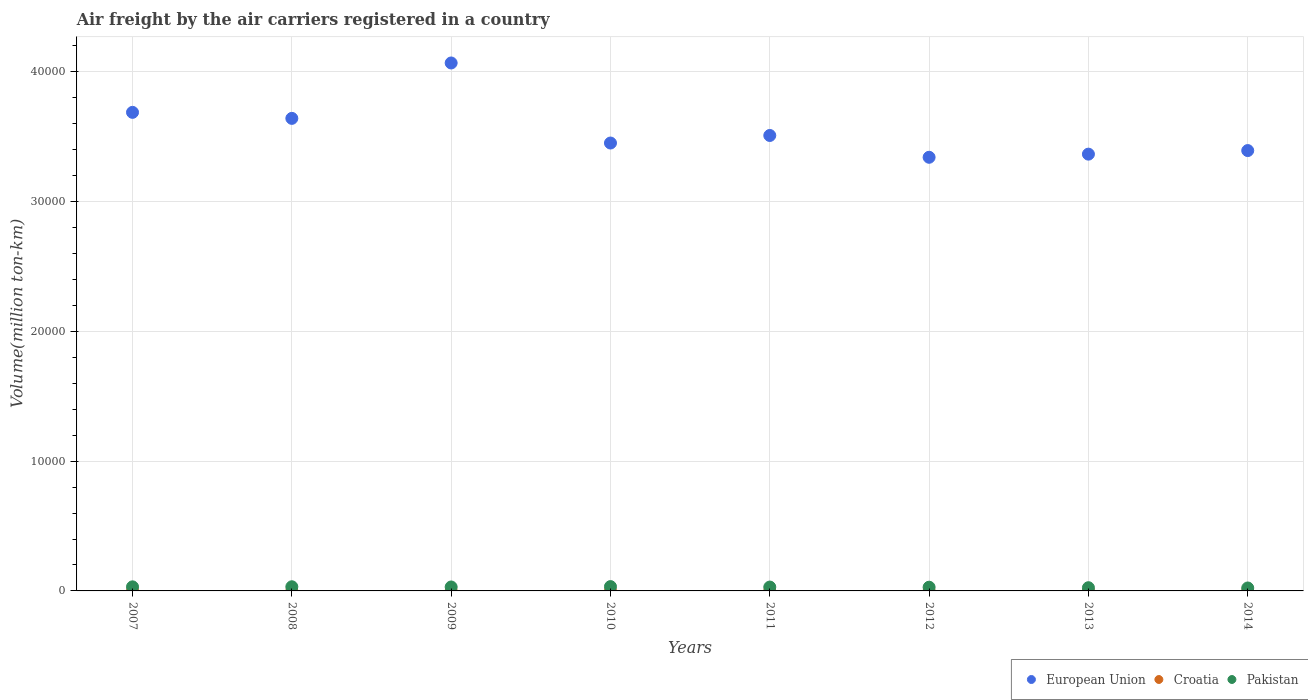Is the number of dotlines equal to the number of legend labels?
Ensure brevity in your answer.  Yes. What is the volume of the air carriers in Pakistan in 2010?
Offer a terse response. 332.96. Across all years, what is the maximum volume of the air carriers in Pakistan?
Offer a very short reply. 332.96. Across all years, what is the minimum volume of the air carriers in European Union?
Make the answer very short. 3.34e+04. What is the total volume of the air carriers in European Union in the graph?
Make the answer very short. 2.85e+05. What is the difference between the volume of the air carriers in European Union in 2012 and that in 2013?
Offer a terse response. -241.89. What is the difference between the volume of the air carriers in Pakistan in 2010 and the volume of the air carriers in European Union in 2008?
Keep it short and to the point. -3.61e+04. What is the average volume of the air carriers in Pakistan per year?
Your response must be concise. 291.08. In the year 2008, what is the difference between the volume of the air carriers in Pakistan and volume of the air carriers in Croatia?
Your answer should be very brief. 317.47. What is the ratio of the volume of the air carriers in Croatia in 2009 to that in 2010?
Your answer should be compact. 1.27. Is the volume of the air carriers in Pakistan in 2007 less than that in 2014?
Provide a succinct answer. No. Is the difference between the volume of the air carriers in Pakistan in 2007 and 2009 greater than the difference between the volume of the air carriers in Croatia in 2007 and 2009?
Your answer should be compact. Yes. What is the difference between the highest and the second highest volume of the air carriers in Pakistan?
Make the answer very short. 13.16. What is the difference between the highest and the lowest volume of the air carriers in Pakistan?
Offer a very short reply. 106.21. In how many years, is the volume of the air carriers in Croatia greater than the average volume of the air carriers in Croatia taken over all years?
Offer a terse response. 4. Is the sum of the volume of the air carriers in European Union in 2007 and 2010 greater than the maximum volume of the air carriers in Pakistan across all years?
Provide a succinct answer. Yes. Does the volume of the air carriers in Croatia monotonically increase over the years?
Offer a terse response. No. Is the volume of the air carriers in European Union strictly greater than the volume of the air carriers in Croatia over the years?
Make the answer very short. Yes. How many years are there in the graph?
Make the answer very short. 8. What is the difference between two consecutive major ticks on the Y-axis?
Your response must be concise. 10000. Does the graph contain any zero values?
Your response must be concise. No. How many legend labels are there?
Give a very brief answer. 3. How are the legend labels stacked?
Your answer should be compact. Horizontal. What is the title of the graph?
Provide a succinct answer. Air freight by the air carriers registered in a country. Does "France" appear as one of the legend labels in the graph?
Your answer should be compact. No. What is the label or title of the X-axis?
Provide a short and direct response. Years. What is the label or title of the Y-axis?
Ensure brevity in your answer.  Volume(million ton-km). What is the Volume(million ton-km) in European Union in 2007?
Ensure brevity in your answer.  3.69e+04. What is the Volume(million ton-km) in Croatia in 2007?
Give a very brief answer. 2.22. What is the Volume(million ton-km) of Pakistan in 2007?
Offer a terse response. 313.87. What is the Volume(million ton-km) in European Union in 2008?
Give a very brief answer. 3.64e+04. What is the Volume(million ton-km) in Croatia in 2008?
Make the answer very short. 2.33. What is the Volume(million ton-km) of Pakistan in 2008?
Your response must be concise. 319.8. What is the Volume(million ton-km) in European Union in 2009?
Make the answer very short. 4.07e+04. What is the Volume(million ton-km) in Croatia in 2009?
Offer a very short reply. 1.92. What is the Volume(million ton-km) of Pakistan in 2009?
Your answer should be compact. 303.9. What is the Volume(million ton-km) in European Union in 2010?
Make the answer very short. 3.45e+04. What is the Volume(million ton-km) in Croatia in 2010?
Your answer should be very brief. 1.52. What is the Volume(million ton-km) in Pakistan in 2010?
Provide a short and direct response. 332.96. What is the Volume(million ton-km) in European Union in 2011?
Give a very brief answer. 3.51e+04. What is the Volume(million ton-km) of Croatia in 2011?
Provide a succinct answer. 1.67. What is the Volume(million ton-km) of Pakistan in 2011?
Your response must be concise. 297.68. What is the Volume(million ton-km) in European Union in 2012?
Offer a terse response. 3.34e+04. What is the Volume(million ton-km) of Croatia in 2012?
Provide a succinct answer. 1.74. What is the Volume(million ton-km) of Pakistan in 2012?
Provide a succinct answer. 286.08. What is the Volume(million ton-km) in European Union in 2013?
Offer a very short reply. 3.37e+04. What is the Volume(million ton-km) in Croatia in 2013?
Provide a succinct answer. 1.47. What is the Volume(million ton-km) of Pakistan in 2013?
Offer a very short reply. 247.6. What is the Volume(million ton-km) in European Union in 2014?
Offer a very short reply. 3.39e+04. What is the Volume(million ton-km) in Croatia in 2014?
Your response must be concise. 0.98. What is the Volume(million ton-km) of Pakistan in 2014?
Ensure brevity in your answer.  226.75. Across all years, what is the maximum Volume(million ton-km) in European Union?
Provide a succinct answer. 4.07e+04. Across all years, what is the maximum Volume(million ton-km) of Croatia?
Keep it short and to the point. 2.33. Across all years, what is the maximum Volume(million ton-km) of Pakistan?
Offer a terse response. 332.96. Across all years, what is the minimum Volume(million ton-km) of European Union?
Give a very brief answer. 3.34e+04. Across all years, what is the minimum Volume(million ton-km) of Croatia?
Make the answer very short. 0.98. Across all years, what is the minimum Volume(million ton-km) in Pakistan?
Offer a very short reply. 226.75. What is the total Volume(million ton-km) of European Union in the graph?
Offer a terse response. 2.85e+05. What is the total Volume(million ton-km) of Croatia in the graph?
Offer a very short reply. 13.84. What is the total Volume(million ton-km) of Pakistan in the graph?
Your answer should be compact. 2328.64. What is the difference between the Volume(million ton-km) in European Union in 2007 and that in 2008?
Offer a very short reply. 463.57. What is the difference between the Volume(million ton-km) in Croatia in 2007 and that in 2008?
Provide a succinct answer. -0.11. What is the difference between the Volume(million ton-km) of Pakistan in 2007 and that in 2008?
Your answer should be very brief. -5.92. What is the difference between the Volume(million ton-km) in European Union in 2007 and that in 2009?
Provide a short and direct response. -3805.88. What is the difference between the Volume(million ton-km) of Croatia in 2007 and that in 2009?
Make the answer very short. 0.3. What is the difference between the Volume(million ton-km) of Pakistan in 2007 and that in 2009?
Offer a terse response. 9.97. What is the difference between the Volume(million ton-km) in European Union in 2007 and that in 2010?
Your answer should be compact. 2363.75. What is the difference between the Volume(million ton-km) in Croatia in 2007 and that in 2010?
Your answer should be very brief. 0.7. What is the difference between the Volume(million ton-km) in Pakistan in 2007 and that in 2010?
Your answer should be very brief. -19.09. What is the difference between the Volume(million ton-km) of European Union in 2007 and that in 2011?
Provide a succinct answer. 1781.69. What is the difference between the Volume(million ton-km) of Croatia in 2007 and that in 2011?
Offer a terse response. 0.54. What is the difference between the Volume(million ton-km) in Pakistan in 2007 and that in 2011?
Your answer should be very brief. 16.19. What is the difference between the Volume(million ton-km) of European Union in 2007 and that in 2012?
Your answer should be compact. 3461.98. What is the difference between the Volume(million ton-km) in Croatia in 2007 and that in 2012?
Ensure brevity in your answer.  0.48. What is the difference between the Volume(million ton-km) in Pakistan in 2007 and that in 2012?
Offer a very short reply. 27.8. What is the difference between the Volume(million ton-km) of European Union in 2007 and that in 2013?
Keep it short and to the point. 3220.09. What is the difference between the Volume(million ton-km) in Croatia in 2007 and that in 2013?
Your answer should be very brief. 0.75. What is the difference between the Volume(million ton-km) in Pakistan in 2007 and that in 2013?
Your answer should be very brief. 66.27. What is the difference between the Volume(million ton-km) of European Union in 2007 and that in 2014?
Offer a very short reply. 2944.59. What is the difference between the Volume(million ton-km) of Croatia in 2007 and that in 2014?
Offer a terse response. 1.24. What is the difference between the Volume(million ton-km) in Pakistan in 2007 and that in 2014?
Provide a short and direct response. 87.12. What is the difference between the Volume(million ton-km) in European Union in 2008 and that in 2009?
Give a very brief answer. -4269.44. What is the difference between the Volume(million ton-km) of Croatia in 2008 and that in 2009?
Offer a terse response. 0.41. What is the difference between the Volume(million ton-km) of Pakistan in 2008 and that in 2009?
Your answer should be compact. 15.89. What is the difference between the Volume(million ton-km) of European Union in 2008 and that in 2010?
Your answer should be compact. 1900.18. What is the difference between the Volume(million ton-km) of Croatia in 2008 and that in 2010?
Offer a terse response. 0.81. What is the difference between the Volume(million ton-km) in Pakistan in 2008 and that in 2010?
Your answer should be very brief. -13.16. What is the difference between the Volume(million ton-km) in European Union in 2008 and that in 2011?
Offer a very short reply. 1318.13. What is the difference between the Volume(million ton-km) of Croatia in 2008 and that in 2011?
Make the answer very short. 0.65. What is the difference between the Volume(million ton-km) of Pakistan in 2008 and that in 2011?
Give a very brief answer. 22.11. What is the difference between the Volume(million ton-km) of European Union in 2008 and that in 2012?
Keep it short and to the point. 2998.41. What is the difference between the Volume(million ton-km) of Croatia in 2008 and that in 2012?
Your response must be concise. 0.59. What is the difference between the Volume(million ton-km) in Pakistan in 2008 and that in 2012?
Make the answer very short. 33.72. What is the difference between the Volume(million ton-km) in European Union in 2008 and that in 2013?
Ensure brevity in your answer.  2756.52. What is the difference between the Volume(million ton-km) in Croatia in 2008 and that in 2013?
Provide a short and direct response. 0.85. What is the difference between the Volume(million ton-km) in Pakistan in 2008 and that in 2013?
Your response must be concise. 72.19. What is the difference between the Volume(million ton-km) in European Union in 2008 and that in 2014?
Provide a succinct answer. 2481.02. What is the difference between the Volume(million ton-km) in Croatia in 2008 and that in 2014?
Provide a succinct answer. 1.35. What is the difference between the Volume(million ton-km) of Pakistan in 2008 and that in 2014?
Make the answer very short. 93.05. What is the difference between the Volume(million ton-km) of European Union in 2009 and that in 2010?
Offer a very short reply. 6169.63. What is the difference between the Volume(million ton-km) of Croatia in 2009 and that in 2010?
Keep it short and to the point. 0.41. What is the difference between the Volume(million ton-km) of Pakistan in 2009 and that in 2010?
Provide a succinct answer. -29.05. What is the difference between the Volume(million ton-km) in European Union in 2009 and that in 2011?
Keep it short and to the point. 5587.57. What is the difference between the Volume(million ton-km) of Croatia in 2009 and that in 2011?
Offer a very short reply. 0.25. What is the difference between the Volume(million ton-km) of Pakistan in 2009 and that in 2011?
Give a very brief answer. 6.22. What is the difference between the Volume(million ton-km) in European Union in 2009 and that in 2012?
Your answer should be very brief. 7267.85. What is the difference between the Volume(million ton-km) of Croatia in 2009 and that in 2012?
Give a very brief answer. 0.18. What is the difference between the Volume(million ton-km) in Pakistan in 2009 and that in 2012?
Ensure brevity in your answer.  17.83. What is the difference between the Volume(million ton-km) in European Union in 2009 and that in 2013?
Give a very brief answer. 7025.96. What is the difference between the Volume(million ton-km) of Croatia in 2009 and that in 2013?
Keep it short and to the point. 0.45. What is the difference between the Volume(million ton-km) in Pakistan in 2009 and that in 2013?
Your answer should be compact. 56.3. What is the difference between the Volume(million ton-km) of European Union in 2009 and that in 2014?
Your answer should be compact. 6750.46. What is the difference between the Volume(million ton-km) of Croatia in 2009 and that in 2014?
Give a very brief answer. 0.94. What is the difference between the Volume(million ton-km) of Pakistan in 2009 and that in 2014?
Your answer should be compact. 77.15. What is the difference between the Volume(million ton-km) of European Union in 2010 and that in 2011?
Keep it short and to the point. -582.06. What is the difference between the Volume(million ton-km) of Croatia in 2010 and that in 2011?
Give a very brief answer. -0.16. What is the difference between the Volume(million ton-km) of Pakistan in 2010 and that in 2011?
Ensure brevity in your answer.  35.27. What is the difference between the Volume(million ton-km) in European Union in 2010 and that in 2012?
Provide a succinct answer. 1098.22. What is the difference between the Volume(million ton-km) of Croatia in 2010 and that in 2012?
Offer a terse response. -0.22. What is the difference between the Volume(million ton-km) in Pakistan in 2010 and that in 2012?
Keep it short and to the point. 46.88. What is the difference between the Volume(million ton-km) of European Union in 2010 and that in 2013?
Ensure brevity in your answer.  856.33. What is the difference between the Volume(million ton-km) of Croatia in 2010 and that in 2013?
Offer a terse response. 0.04. What is the difference between the Volume(million ton-km) of Pakistan in 2010 and that in 2013?
Provide a succinct answer. 85.36. What is the difference between the Volume(million ton-km) of European Union in 2010 and that in 2014?
Provide a short and direct response. 580.84. What is the difference between the Volume(million ton-km) in Croatia in 2010 and that in 2014?
Make the answer very short. 0.54. What is the difference between the Volume(million ton-km) in Pakistan in 2010 and that in 2014?
Provide a succinct answer. 106.21. What is the difference between the Volume(million ton-km) in European Union in 2011 and that in 2012?
Provide a succinct answer. 1680.28. What is the difference between the Volume(million ton-km) of Croatia in 2011 and that in 2012?
Offer a very short reply. -0.06. What is the difference between the Volume(million ton-km) in Pakistan in 2011 and that in 2012?
Your answer should be compact. 11.61. What is the difference between the Volume(million ton-km) in European Union in 2011 and that in 2013?
Provide a succinct answer. 1438.39. What is the difference between the Volume(million ton-km) of Croatia in 2011 and that in 2013?
Your answer should be compact. 0.2. What is the difference between the Volume(million ton-km) in Pakistan in 2011 and that in 2013?
Provide a succinct answer. 50.08. What is the difference between the Volume(million ton-km) of European Union in 2011 and that in 2014?
Provide a succinct answer. 1162.89. What is the difference between the Volume(million ton-km) of Croatia in 2011 and that in 2014?
Offer a very short reply. 0.7. What is the difference between the Volume(million ton-km) of Pakistan in 2011 and that in 2014?
Offer a very short reply. 70.93. What is the difference between the Volume(million ton-km) in European Union in 2012 and that in 2013?
Make the answer very short. -241.89. What is the difference between the Volume(million ton-km) in Croatia in 2012 and that in 2013?
Give a very brief answer. 0.27. What is the difference between the Volume(million ton-km) in Pakistan in 2012 and that in 2013?
Make the answer very short. 38.47. What is the difference between the Volume(million ton-km) of European Union in 2012 and that in 2014?
Offer a terse response. -517.39. What is the difference between the Volume(million ton-km) of Croatia in 2012 and that in 2014?
Ensure brevity in your answer.  0.76. What is the difference between the Volume(million ton-km) in Pakistan in 2012 and that in 2014?
Keep it short and to the point. 59.32. What is the difference between the Volume(million ton-km) of European Union in 2013 and that in 2014?
Provide a succinct answer. -275.5. What is the difference between the Volume(million ton-km) in Croatia in 2013 and that in 2014?
Your answer should be compact. 0.5. What is the difference between the Volume(million ton-km) of Pakistan in 2013 and that in 2014?
Your answer should be compact. 20.85. What is the difference between the Volume(million ton-km) of European Union in 2007 and the Volume(million ton-km) of Croatia in 2008?
Offer a very short reply. 3.69e+04. What is the difference between the Volume(million ton-km) in European Union in 2007 and the Volume(million ton-km) in Pakistan in 2008?
Keep it short and to the point. 3.66e+04. What is the difference between the Volume(million ton-km) of Croatia in 2007 and the Volume(million ton-km) of Pakistan in 2008?
Provide a succinct answer. -317.58. What is the difference between the Volume(million ton-km) of European Union in 2007 and the Volume(million ton-km) of Croatia in 2009?
Keep it short and to the point. 3.69e+04. What is the difference between the Volume(million ton-km) of European Union in 2007 and the Volume(million ton-km) of Pakistan in 2009?
Your answer should be very brief. 3.66e+04. What is the difference between the Volume(million ton-km) in Croatia in 2007 and the Volume(million ton-km) in Pakistan in 2009?
Provide a short and direct response. -301.69. What is the difference between the Volume(million ton-km) in European Union in 2007 and the Volume(million ton-km) in Croatia in 2010?
Ensure brevity in your answer.  3.69e+04. What is the difference between the Volume(million ton-km) in European Union in 2007 and the Volume(million ton-km) in Pakistan in 2010?
Give a very brief answer. 3.65e+04. What is the difference between the Volume(million ton-km) in Croatia in 2007 and the Volume(million ton-km) in Pakistan in 2010?
Provide a short and direct response. -330.74. What is the difference between the Volume(million ton-km) in European Union in 2007 and the Volume(million ton-km) in Croatia in 2011?
Offer a very short reply. 3.69e+04. What is the difference between the Volume(million ton-km) of European Union in 2007 and the Volume(million ton-km) of Pakistan in 2011?
Your answer should be very brief. 3.66e+04. What is the difference between the Volume(million ton-km) of Croatia in 2007 and the Volume(million ton-km) of Pakistan in 2011?
Provide a short and direct response. -295.47. What is the difference between the Volume(million ton-km) in European Union in 2007 and the Volume(million ton-km) in Croatia in 2012?
Make the answer very short. 3.69e+04. What is the difference between the Volume(million ton-km) of European Union in 2007 and the Volume(million ton-km) of Pakistan in 2012?
Ensure brevity in your answer.  3.66e+04. What is the difference between the Volume(million ton-km) in Croatia in 2007 and the Volume(million ton-km) in Pakistan in 2012?
Offer a terse response. -283.86. What is the difference between the Volume(million ton-km) of European Union in 2007 and the Volume(million ton-km) of Croatia in 2013?
Keep it short and to the point. 3.69e+04. What is the difference between the Volume(million ton-km) of European Union in 2007 and the Volume(million ton-km) of Pakistan in 2013?
Your response must be concise. 3.66e+04. What is the difference between the Volume(million ton-km) of Croatia in 2007 and the Volume(million ton-km) of Pakistan in 2013?
Provide a succinct answer. -245.38. What is the difference between the Volume(million ton-km) in European Union in 2007 and the Volume(million ton-km) in Croatia in 2014?
Offer a terse response. 3.69e+04. What is the difference between the Volume(million ton-km) of European Union in 2007 and the Volume(million ton-km) of Pakistan in 2014?
Provide a short and direct response. 3.67e+04. What is the difference between the Volume(million ton-km) of Croatia in 2007 and the Volume(million ton-km) of Pakistan in 2014?
Make the answer very short. -224.53. What is the difference between the Volume(million ton-km) of European Union in 2008 and the Volume(million ton-km) of Croatia in 2009?
Provide a succinct answer. 3.64e+04. What is the difference between the Volume(million ton-km) of European Union in 2008 and the Volume(million ton-km) of Pakistan in 2009?
Provide a short and direct response. 3.61e+04. What is the difference between the Volume(million ton-km) of Croatia in 2008 and the Volume(million ton-km) of Pakistan in 2009?
Your answer should be compact. -301.58. What is the difference between the Volume(million ton-km) in European Union in 2008 and the Volume(million ton-km) in Croatia in 2010?
Your response must be concise. 3.64e+04. What is the difference between the Volume(million ton-km) of European Union in 2008 and the Volume(million ton-km) of Pakistan in 2010?
Ensure brevity in your answer.  3.61e+04. What is the difference between the Volume(million ton-km) of Croatia in 2008 and the Volume(million ton-km) of Pakistan in 2010?
Offer a very short reply. -330.63. What is the difference between the Volume(million ton-km) in European Union in 2008 and the Volume(million ton-km) in Croatia in 2011?
Give a very brief answer. 3.64e+04. What is the difference between the Volume(million ton-km) in European Union in 2008 and the Volume(million ton-km) in Pakistan in 2011?
Provide a short and direct response. 3.61e+04. What is the difference between the Volume(million ton-km) of Croatia in 2008 and the Volume(million ton-km) of Pakistan in 2011?
Your response must be concise. -295.36. What is the difference between the Volume(million ton-km) of European Union in 2008 and the Volume(million ton-km) of Croatia in 2012?
Provide a succinct answer. 3.64e+04. What is the difference between the Volume(million ton-km) of European Union in 2008 and the Volume(million ton-km) of Pakistan in 2012?
Provide a succinct answer. 3.61e+04. What is the difference between the Volume(million ton-km) in Croatia in 2008 and the Volume(million ton-km) in Pakistan in 2012?
Give a very brief answer. -283.75. What is the difference between the Volume(million ton-km) in European Union in 2008 and the Volume(million ton-km) in Croatia in 2013?
Your response must be concise. 3.64e+04. What is the difference between the Volume(million ton-km) of European Union in 2008 and the Volume(million ton-km) of Pakistan in 2013?
Your answer should be compact. 3.62e+04. What is the difference between the Volume(million ton-km) in Croatia in 2008 and the Volume(million ton-km) in Pakistan in 2013?
Make the answer very short. -245.28. What is the difference between the Volume(million ton-km) of European Union in 2008 and the Volume(million ton-km) of Croatia in 2014?
Offer a very short reply. 3.64e+04. What is the difference between the Volume(million ton-km) of European Union in 2008 and the Volume(million ton-km) of Pakistan in 2014?
Your answer should be very brief. 3.62e+04. What is the difference between the Volume(million ton-km) in Croatia in 2008 and the Volume(million ton-km) in Pakistan in 2014?
Offer a terse response. -224.43. What is the difference between the Volume(million ton-km) in European Union in 2009 and the Volume(million ton-km) in Croatia in 2010?
Your response must be concise. 4.07e+04. What is the difference between the Volume(million ton-km) in European Union in 2009 and the Volume(million ton-km) in Pakistan in 2010?
Ensure brevity in your answer.  4.04e+04. What is the difference between the Volume(million ton-km) of Croatia in 2009 and the Volume(million ton-km) of Pakistan in 2010?
Provide a succinct answer. -331.04. What is the difference between the Volume(million ton-km) of European Union in 2009 and the Volume(million ton-km) of Croatia in 2011?
Give a very brief answer. 4.07e+04. What is the difference between the Volume(million ton-km) in European Union in 2009 and the Volume(million ton-km) in Pakistan in 2011?
Provide a succinct answer. 4.04e+04. What is the difference between the Volume(million ton-km) of Croatia in 2009 and the Volume(million ton-km) of Pakistan in 2011?
Provide a short and direct response. -295.76. What is the difference between the Volume(million ton-km) in European Union in 2009 and the Volume(million ton-km) in Croatia in 2012?
Ensure brevity in your answer.  4.07e+04. What is the difference between the Volume(million ton-km) of European Union in 2009 and the Volume(million ton-km) of Pakistan in 2012?
Your answer should be compact. 4.04e+04. What is the difference between the Volume(million ton-km) of Croatia in 2009 and the Volume(million ton-km) of Pakistan in 2012?
Keep it short and to the point. -284.15. What is the difference between the Volume(million ton-km) of European Union in 2009 and the Volume(million ton-km) of Croatia in 2013?
Give a very brief answer. 4.07e+04. What is the difference between the Volume(million ton-km) in European Union in 2009 and the Volume(million ton-km) in Pakistan in 2013?
Your answer should be very brief. 4.04e+04. What is the difference between the Volume(million ton-km) in Croatia in 2009 and the Volume(million ton-km) in Pakistan in 2013?
Make the answer very short. -245.68. What is the difference between the Volume(million ton-km) of European Union in 2009 and the Volume(million ton-km) of Croatia in 2014?
Ensure brevity in your answer.  4.07e+04. What is the difference between the Volume(million ton-km) in European Union in 2009 and the Volume(million ton-km) in Pakistan in 2014?
Offer a terse response. 4.05e+04. What is the difference between the Volume(million ton-km) in Croatia in 2009 and the Volume(million ton-km) in Pakistan in 2014?
Keep it short and to the point. -224.83. What is the difference between the Volume(million ton-km) of European Union in 2010 and the Volume(million ton-km) of Croatia in 2011?
Keep it short and to the point. 3.45e+04. What is the difference between the Volume(million ton-km) of European Union in 2010 and the Volume(million ton-km) of Pakistan in 2011?
Provide a short and direct response. 3.42e+04. What is the difference between the Volume(million ton-km) of Croatia in 2010 and the Volume(million ton-km) of Pakistan in 2011?
Ensure brevity in your answer.  -296.17. What is the difference between the Volume(million ton-km) of European Union in 2010 and the Volume(million ton-km) of Croatia in 2012?
Provide a succinct answer. 3.45e+04. What is the difference between the Volume(million ton-km) of European Union in 2010 and the Volume(million ton-km) of Pakistan in 2012?
Provide a short and direct response. 3.42e+04. What is the difference between the Volume(million ton-km) in Croatia in 2010 and the Volume(million ton-km) in Pakistan in 2012?
Give a very brief answer. -284.56. What is the difference between the Volume(million ton-km) of European Union in 2010 and the Volume(million ton-km) of Croatia in 2013?
Your response must be concise. 3.45e+04. What is the difference between the Volume(million ton-km) of European Union in 2010 and the Volume(million ton-km) of Pakistan in 2013?
Your answer should be compact. 3.43e+04. What is the difference between the Volume(million ton-km) of Croatia in 2010 and the Volume(million ton-km) of Pakistan in 2013?
Make the answer very short. -246.09. What is the difference between the Volume(million ton-km) of European Union in 2010 and the Volume(million ton-km) of Croatia in 2014?
Give a very brief answer. 3.45e+04. What is the difference between the Volume(million ton-km) in European Union in 2010 and the Volume(million ton-km) in Pakistan in 2014?
Provide a succinct answer. 3.43e+04. What is the difference between the Volume(million ton-km) in Croatia in 2010 and the Volume(million ton-km) in Pakistan in 2014?
Your answer should be compact. -225.24. What is the difference between the Volume(million ton-km) of European Union in 2011 and the Volume(million ton-km) of Croatia in 2012?
Make the answer very short. 3.51e+04. What is the difference between the Volume(million ton-km) in European Union in 2011 and the Volume(million ton-km) in Pakistan in 2012?
Your answer should be very brief. 3.48e+04. What is the difference between the Volume(million ton-km) in Croatia in 2011 and the Volume(million ton-km) in Pakistan in 2012?
Provide a succinct answer. -284.4. What is the difference between the Volume(million ton-km) of European Union in 2011 and the Volume(million ton-km) of Croatia in 2013?
Provide a short and direct response. 3.51e+04. What is the difference between the Volume(million ton-km) in European Union in 2011 and the Volume(million ton-km) in Pakistan in 2013?
Make the answer very short. 3.49e+04. What is the difference between the Volume(million ton-km) of Croatia in 2011 and the Volume(million ton-km) of Pakistan in 2013?
Offer a very short reply. -245.93. What is the difference between the Volume(million ton-km) in European Union in 2011 and the Volume(million ton-km) in Croatia in 2014?
Provide a succinct answer. 3.51e+04. What is the difference between the Volume(million ton-km) of European Union in 2011 and the Volume(million ton-km) of Pakistan in 2014?
Give a very brief answer. 3.49e+04. What is the difference between the Volume(million ton-km) of Croatia in 2011 and the Volume(million ton-km) of Pakistan in 2014?
Your answer should be very brief. -225.08. What is the difference between the Volume(million ton-km) in European Union in 2012 and the Volume(million ton-km) in Croatia in 2013?
Give a very brief answer. 3.34e+04. What is the difference between the Volume(million ton-km) of European Union in 2012 and the Volume(million ton-km) of Pakistan in 2013?
Give a very brief answer. 3.32e+04. What is the difference between the Volume(million ton-km) of Croatia in 2012 and the Volume(million ton-km) of Pakistan in 2013?
Make the answer very short. -245.86. What is the difference between the Volume(million ton-km) in European Union in 2012 and the Volume(million ton-km) in Croatia in 2014?
Provide a succinct answer. 3.34e+04. What is the difference between the Volume(million ton-km) in European Union in 2012 and the Volume(million ton-km) in Pakistan in 2014?
Make the answer very short. 3.32e+04. What is the difference between the Volume(million ton-km) in Croatia in 2012 and the Volume(million ton-km) in Pakistan in 2014?
Provide a short and direct response. -225.01. What is the difference between the Volume(million ton-km) of European Union in 2013 and the Volume(million ton-km) of Croatia in 2014?
Offer a very short reply. 3.37e+04. What is the difference between the Volume(million ton-km) of European Union in 2013 and the Volume(million ton-km) of Pakistan in 2014?
Make the answer very short. 3.34e+04. What is the difference between the Volume(million ton-km) of Croatia in 2013 and the Volume(million ton-km) of Pakistan in 2014?
Provide a succinct answer. -225.28. What is the average Volume(million ton-km) in European Union per year?
Provide a short and direct response. 3.56e+04. What is the average Volume(million ton-km) in Croatia per year?
Provide a succinct answer. 1.73. What is the average Volume(million ton-km) of Pakistan per year?
Your answer should be very brief. 291.08. In the year 2007, what is the difference between the Volume(million ton-km) in European Union and Volume(million ton-km) in Croatia?
Provide a succinct answer. 3.69e+04. In the year 2007, what is the difference between the Volume(million ton-km) in European Union and Volume(million ton-km) in Pakistan?
Your answer should be compact. 3.66e+04. In the year 2007, what is the difference between the Volume(million ton-km) in Croatia and Volume(million ton-km) in Pakistan?
Your response must be concise. -311.65. In the year 2008, what is the difference between the Volume(million ton-km) of European Union and Volume(million ton-km) of Croatia?
Your answer should be compact. 3.64e+04. In the year 2008, what is the difference between the Volume(million ton-km) in European Union and Volume(million ton-km) in Pakistan?
Keep it short and to the point. 3.61e+04. In the year 2008, what is the difference between the Volume(million ton-km) in Croatia and Volume(million ton-km) in Pakistan?
Your answer should be compact. -317.47. In the year 2009, what is the difference between the Volume(million ton-km) in European Union and Volume(million ton-km) in Croatia?
Offer a very short reply. 4.07e+04. In the year 2009, what is the difference between the Volume(million ton-km) in European Union and Volume(million ton-km) in Pakistan?
Keep it short and to the point. 4.04e+04. In the year 2009, what is the difference between the Volume(million ton-km) in Croatia and Volume(million ton-km) in Pakistan?
Provide a succinct answer. -301.98. In the year 2010, what is the difference between the Volume(million ton-km) in European Union and Volume(million ton-km) in Croatia?
Your answer should be compact. 3.45e+04. In the year 2010, what is the difference between the Volume(million ton-km) in European Union and Volume(million ton-km) in Pakistan?
Give a very brief answer. 3.42e+04. In the year 2010, what is the difference between the Volume(million ton-km) in Croatia and Volume(million ton-km) in Pakistan?
Ensure brevity in your answer.  -331.44. In the year 2011, what is the difference between the Volume(million ton-km) of European Union and Volume(million ton-km) of Croatia?
Offer a very short reply. 3.51e+04. In the year 2011, what is the difference between the Volume(million ton-km) of European Union and Volume(million ton-km) of Pakistan?
Provide a succinct answer. 3.48e+04. In the year 2011, what is the difference between the Volume(million ton-km) of Croatia and Volume(million ton-km) of Pakistan?
Make the answer very short. -296.01. In the year 2012, what is the difference between the Volume(million ton-km) of European Union and Volume(million ton-km) of Croatia?
Your answer should be very brief. 3.34e+04. In the year 2012, what is the difference between the Volume(million ton-km) in European Union and Volume(million ton-km) in Pakistan?
Your response must be concise. 3.31e+04. In the year 2012, what is the difference between the Volume(million ton-km) in Croatia and Volume(million ton-km) in Pakistan?
Keep it short and to the point. -284.34. In the year 2013, what is the difference between the Volume(million ton-km) of European Union and Volume(million ton-km) of Croatia?
Your answer should be compact. 3.37e+04. In the year 2013, what is the difference between the Volume(million ton-km) in European Union and Volume(million ton-km) in Pakistan?
Offer a terse response. 3.34e+04. In the year 2013, what is the difference between the Volume(million ton-km) of Croatia and Volume(million ton-km) of Pakistan?
Your answer should be very brief. -246.13. In the year 2014, what is the difference between the Volume(million ton-km) in European Union and Volume(million ton-km) in Croatia?
Give a very brief answer. 3.39e+04. In the year 2014, what is the difference between the Volume(million ton-km) of European Union and Volume(million ton-km) of Pakistan?
Your response must be concise. 3.37e+04. In the year 2014, what is the difference between the Volume(million ton-km) in Croatia and Volume(million ton-km) in Pakistan?
Your response must be concise. -225.77. What is the ratio of the Volume(million ton-km) in European Union in 2007 to that in 2008?
Keep it short and to the point. 1.01. What is the ratio of the Volume(million ton-km) of Croatia in 2007 to that in 2008?
Offer a terse response. 0.95. What is the ratio of the Volume(million ton-km) in Pakistan in 2007 to that in 2008?
Give a very brief answer. 0.98. What is the ratio of the Volume(million ton-km) of European Union in 2007 to that in 2009?
Give a very brief answer. 0.91. What is the ratio of the Volume(million ton-km) of Croatia in 2007 to that in 2009?
Your answer should be compact. 1.15. What is the ratio of the Volume(million ton-km) in Pakistan in 2007 to that in 2009?
Give a very brief answer. 1.03. What is the ratio of the Volume(million ton-km) in European Union in 2007 to that in 2010?
Your response must be concise. 1.07. What is the ratio of the Volume(million ton-km) of Croatia in 2007 to that in 2010?
Your response must be concise. 1.46. What is the ratio of the Volume(million ton-km) in Pakistan in 2007 to that in 2010?
Keep it short and to the point. 0.94. What is the ratio of the Volume(million ton-km) of European Union in 2007 to that in 2011?
Give a very brief answer. 1.05. What is the ratio of the Volume(million ton-km) in Croatia in 2007 to that in 2011?
Offer a terse response. 1.32. What is the ratio of the Volume(million ton-km) of Pakistan in 2007 to that in 2011?
Make the answer very short. 1.05. What is the ratio of the Volume(million ton-km) of European Union in 2007 to that in 2012?
Give a very brief answer. 1.1. What is the ratio of the Volume(million ton-km) in Croatia in 2007 to that in 2012?
Give a very brief answer. 1.28. What is the ratio of the Volume(million ton-km) in Pakistan in 2007 to that in 2012?
Ensure brevity in your answer.  1.1. What is the ratio of the Volume(million ton-km) of European Union in 2007 to that in 2013?
Your answer should be compact. 1.1. What is the ratio of the Volume(million ton-km) in Croatia in 2007 to that in 2013?
Your answer should be compact. 1.51. What is the ratio of the Volume(million ton-km) of Pakistan in 2007 to that in 2013?
Ensure brevity in your answer.  1.27. What is the ratio of the Volume(million ton-km) in European Union in 2007 to that in 2014?
Your response must be concise. 1.09. What is the ratio of the Volume(million ton-km) of Croatia in 2007 to that in 2014?
Provide a succinct answer. 2.27. What is the ratio of the Volume(million ton-km) in Pakistan in 2007 to that in 2014?
Provide a succinct answer. 1.38. What is the ratio of the Volume(million ton-km) in European Union in 2008 to that in 2009?
Keep it short and to the point. 0.9. What is the ratio of the Volume(million ton-km) in Croatia in 2008 to that in 2009?
Offer a terse response. 1.21. What is the ratio of the Volume(million ton-km) of Pakistan in 2008 to that in 2009?
Ensure brevity in your answer.  1.05. What is the ratio of the Volume(million ton-km) in European Union in 2008 to that in 2010?
Give a very brief answer. 1.06. What is the ratio of the Volume(million ton-km) of Croatia in 2008 to that in 2010?
Keep it short and to the point. 1.53. What is the ratio of the Volume(million ton-km) in Pakistan in 2008 to that in 2010?
Your answer should be compact. 0.96. What is the ratio of the Volume(million ton-km) in European Union in 2008 to that in 2011?
Your response must be concise. 1.04. What is the ratio of the Volume(million ton-km) in Croatia in 2008 to that in 2011?
Your answer should be compact. 1.39. What is the ratio of the Volume(million ton-km) of Pakistan in 2008 to that in 2011?
Offer a very short reply. 1.07. What is the ratio of the Volume(million ton-km) in European Union in 2008 to that in 2012?
Your answer should be very brief. 1.09. What is the ratio of the Volume(million ton-km) in Croatia in 2008 to that in 2012?
Your answer should be very brief. 1.34. What is the ratio of the Volume(million ton-km) of Pakistan in 2008 to that in 2012?
Provide a succinct answer. 1.12. What is the ratio of the Volume(million ton-km) of European Union in 2008 to that in 2013?
Provide a short and direct response. 1.08. What is the ratio of the Volume(million ton-km) in Croatia in 2008 to that in 2013?
Provide a succinct answer. 1.58. What is the ratio of the Volume(million ton-km) in Pakistan in 2008 to that in 2013?
Offer a very short reply. 1.29. What is the ratio of the Volume(million ton-km) in European Union in 2008 to that in 2014?
Offer a terse response. 1.07. What is the ratio of the Volume(million ton-km) in Croatia in 2008 to that in 2014?
Your answer should be very brief. 2.38. What is the ratio of the Volume(million ton-km) of Pakistan in 2008 to that in 2014?
Ensure brevity in your answer.  1.41. What is the ratio of the Volume(million ton-km) in European Union in 2009 to that in 2010?
Make the answer very short. 1.18. What is the ratio of the Volume(million ton-km) of Croatia in 2009 to that in 2010?
Ensure brevity in your answer.  1.27. What is the ratio of the Volume(million ton-km) in Pakistan in 2009 to that in 2010?
Provide a short and direct response. 0.91. What is the ratio of the Volume(million ton-km) in European Union in 2009 to that in 2011?
Provide a succinct answer. 1.16. What is the ratio of the Volume(million ton-km) of Croatia in 2009 to that in 2011?
Make the answer very short. 1.15. What is the ratio of the Volume(million ton-km) of Pakistan in 2009 to that in 2011?
Provide a succinct answer. 1.02. What is the ratio of the Volume(million ton-km) of European Union in 2009 to that in 2012?
Your answer should be very brief. 1.22. What is the ratio of the Volume(million ton-km) of Croatia in 2009 to that in 2012?
Give a very brief answer. 1.11. What is the ratio of the Volume(million ton-km) in Pakistan in 2009 to that in 2012?
Give a very brief answer. 1.06. What is the ratio of the Volume(million ton-km) in European Union in 2009 to that in 2013?
Keep it short and to the point. 1.21. What is the ratio of the Volume(million ton-km) in Croatia in 2009 to that in 2013?
Provide a succinct answer. 1.3. What is the ratio of the Volume(million ton-km) of Pakistan in 2009 to that in 2013?
Your answer should be very brief. 1.23. What is the ratio of the Volume(million ton-km) in European Union in 2009 to that in 2014?
Ensure brevity in your answer.  1.2. What is the ratio of the Volume(million ton-km) in Croatia in 2009 to that in 2014?
Your answer should be very brief. 1.97. What is the ratio of the Volume(million ton-km) in Pakistan in 2009 to that in 2014?
Your answer should be compact. 1.34. What is the ratio of the Volume(million ton-km) of European Union in 2010 to that in 2011?
Make the answer very short. 0.98. What is the ratio of the Volume(million ton-km) of Croatia in 2010 to that in 2011?
Keep it short and to the point. 0.91. What is the ratio of the Volume(million ton-km) in Pakistan in 2010 to that in 2011?
Your answer should be compact. 1.12. What is the ratio of the Volume(million ton-km) of European Union in 2010 to that in 2012?
Give a very brief answer. 1.03. What is the ratio of the Volume(million ton-km) of Croatia in 2010 to that in 2012?
Keep it short and to the point. 0.87. What is the ratio of the Volume(million ton-km) in Pakistan in 2010 to that in 2012?
Your response must be concise. 1.16. What is the ratio of the Volume(million ton-km) in European Union in 2010 to that in 2013?
Keep it short and to the point. 1.03. What is the ratio of the Volume(million ton-km) of Croatia in 2010 to that in 2013?
Your response must be concise. 1.03. What is the ratio of the Volume(million ton-km) in Pakistan in 2010 to that in 2013?
Provide a short and direct response. 1.34. What is the ratio of the Volume(million ton-km) in European Union in 2010 to that in 2014?
Ensure brevity in your answer.  1.02. What is the ratio of the Volume(million ton-km) of Croatia in 2010 to that in 2014?
Your response must be concise. 1.55. What is the ratio of the Volume(million ton-km) of Pakistan in 2010 to that in 2014?
Ensure brevity in your answer.  1.47. What is the ratio of the Volume(million ton-km) of European Union in 2011 to that in 2012?
Your answer should be very brief. 1.05. What is the ratio of the Volume(million ton-km) in Croatia in 2011 to that in 2012?
Your answer should be compact. 0.96. What is the ratio of the Volume(million ton-km) in Pakistan in 2011 to that in 2012?
Provide a succinct answer. 1.04. What is the ratio of the Volume(million ton-km) of European Union in 2011 to that in 2013?
Make the answer very short. 1.04. What is the ratio of the Volume(million ton-km) of Croatia in 2011 to that in 2013?
Provide a succinct answer. 1.14. What is the ratio of the Volume(million ton-km) of Pakistan in 2011 to that in 2013?
Your answer should be very brief. 1.2. What is the ratio of the Volume(million ton-km) of European Union in 2011 to that in 2014?
Ensure brevity in your answer.  1.03. What is the ratio of the Volume(million ton-km) in Croatia in 2011 to that in 2014?
Your answer should be compact. 1.72. What is the ratio of the Volume(million ton-km) of Pakistan in 2011 to that in 2014?
Provide a succinct answer. 1.31. What is the ratio of the Volume(million ton-km) in European Union in 2012 to that in 2013?
Your answer should be compact. 0.99. What is the ratio of the Volume(million ton-km) in Croatia in 2012 to that in 2013?
Your response must be concise. 1.18. What is the ratio of the Volume(million ton-km) in Pakistan in 2012 to that in 2013?
Make the answer very short. 1.16. What is the ratio of the Volume(million ton-km) of Croatia in 2012 to that in 2014?
Provide a succinct answer. 1.78. What is the ratio of the Volume(million ton-km) of Pakistan in 2012 to that in 2014?
Your answer should be very brief. 1.26. What is the ratio of the Volume(million ton-km) in European Union in 2013 to that in 2014?
Your answer should be compact. 0.99. What is the ratio of the Volume(million ton-km) of Croatia in 2013 to that in 2014?
Provide a short and direct response. 1.51. What is the ratio of the Volume(million ton-km) in Pakistan in 2013 to that in 2014?
Your answer should be compact. 1.09. What is the difference between the highest and the second highest Volume(million ton-km) of European Union?
Provide a short and direct response. 3805.88. What is the difference between the highest and the second highest Volume(million ton-km) of Croatia?
Make the answer very short. 0.11. What is the difference between the highest and the second highest Volume(million ton-km) in Pakistan?
Your answer should be very brief. 13.16. What is the difference between the highest and the lowest Volume(million ton-km) of European Union?
Your answer should be very brief. 7267.85. What is the difference between the highest and the lowest Volume(million ton-km) in Croatia?
Ensure brevity in your answer.  1.35. What is the difference between the highest and the lowest Volume(million ton-km) in Pakistan?
Your answer should be very brief. 106.21. 